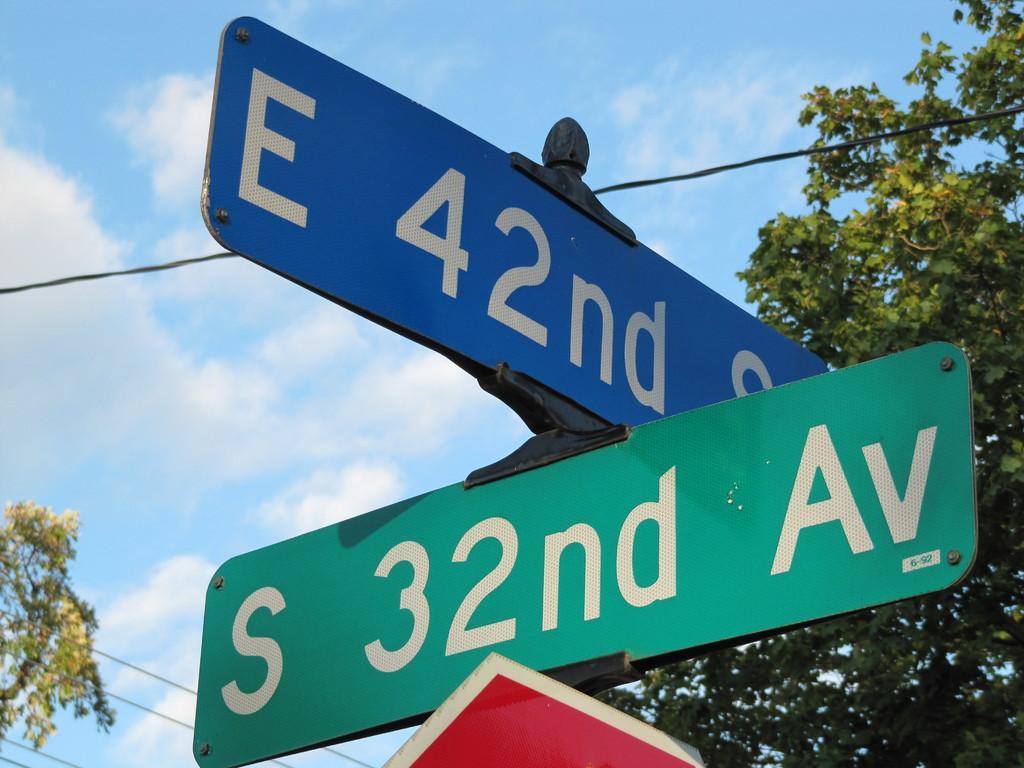Please provide a concise description of this image. In the foreground of the image we can see three sign boards. In the background, we can see a group of trees, cables and cloudy sky. 